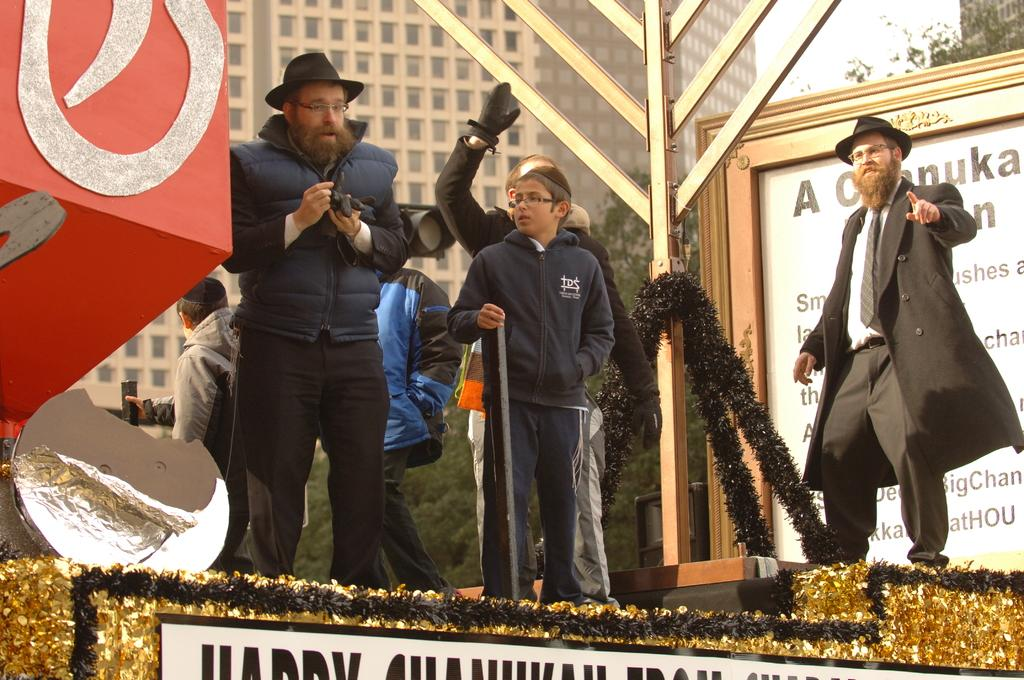What are the people in the image doing? The people are standing on stage in the image. What can be seen hanging or displayed in the image? There is a banner in the image. What type of natural environment is visible in the image? There are trees visible in the image. What type of man-made structure can be seen in the image? There is a building in the image. What type of stamp is being used by the people on stage in the image? There is no stamp present in the image; the people are standing on stage. What type of machine can be seen operating in the background of the image? There is no machine present in the image; the focus is on the people on stage and the banner. 